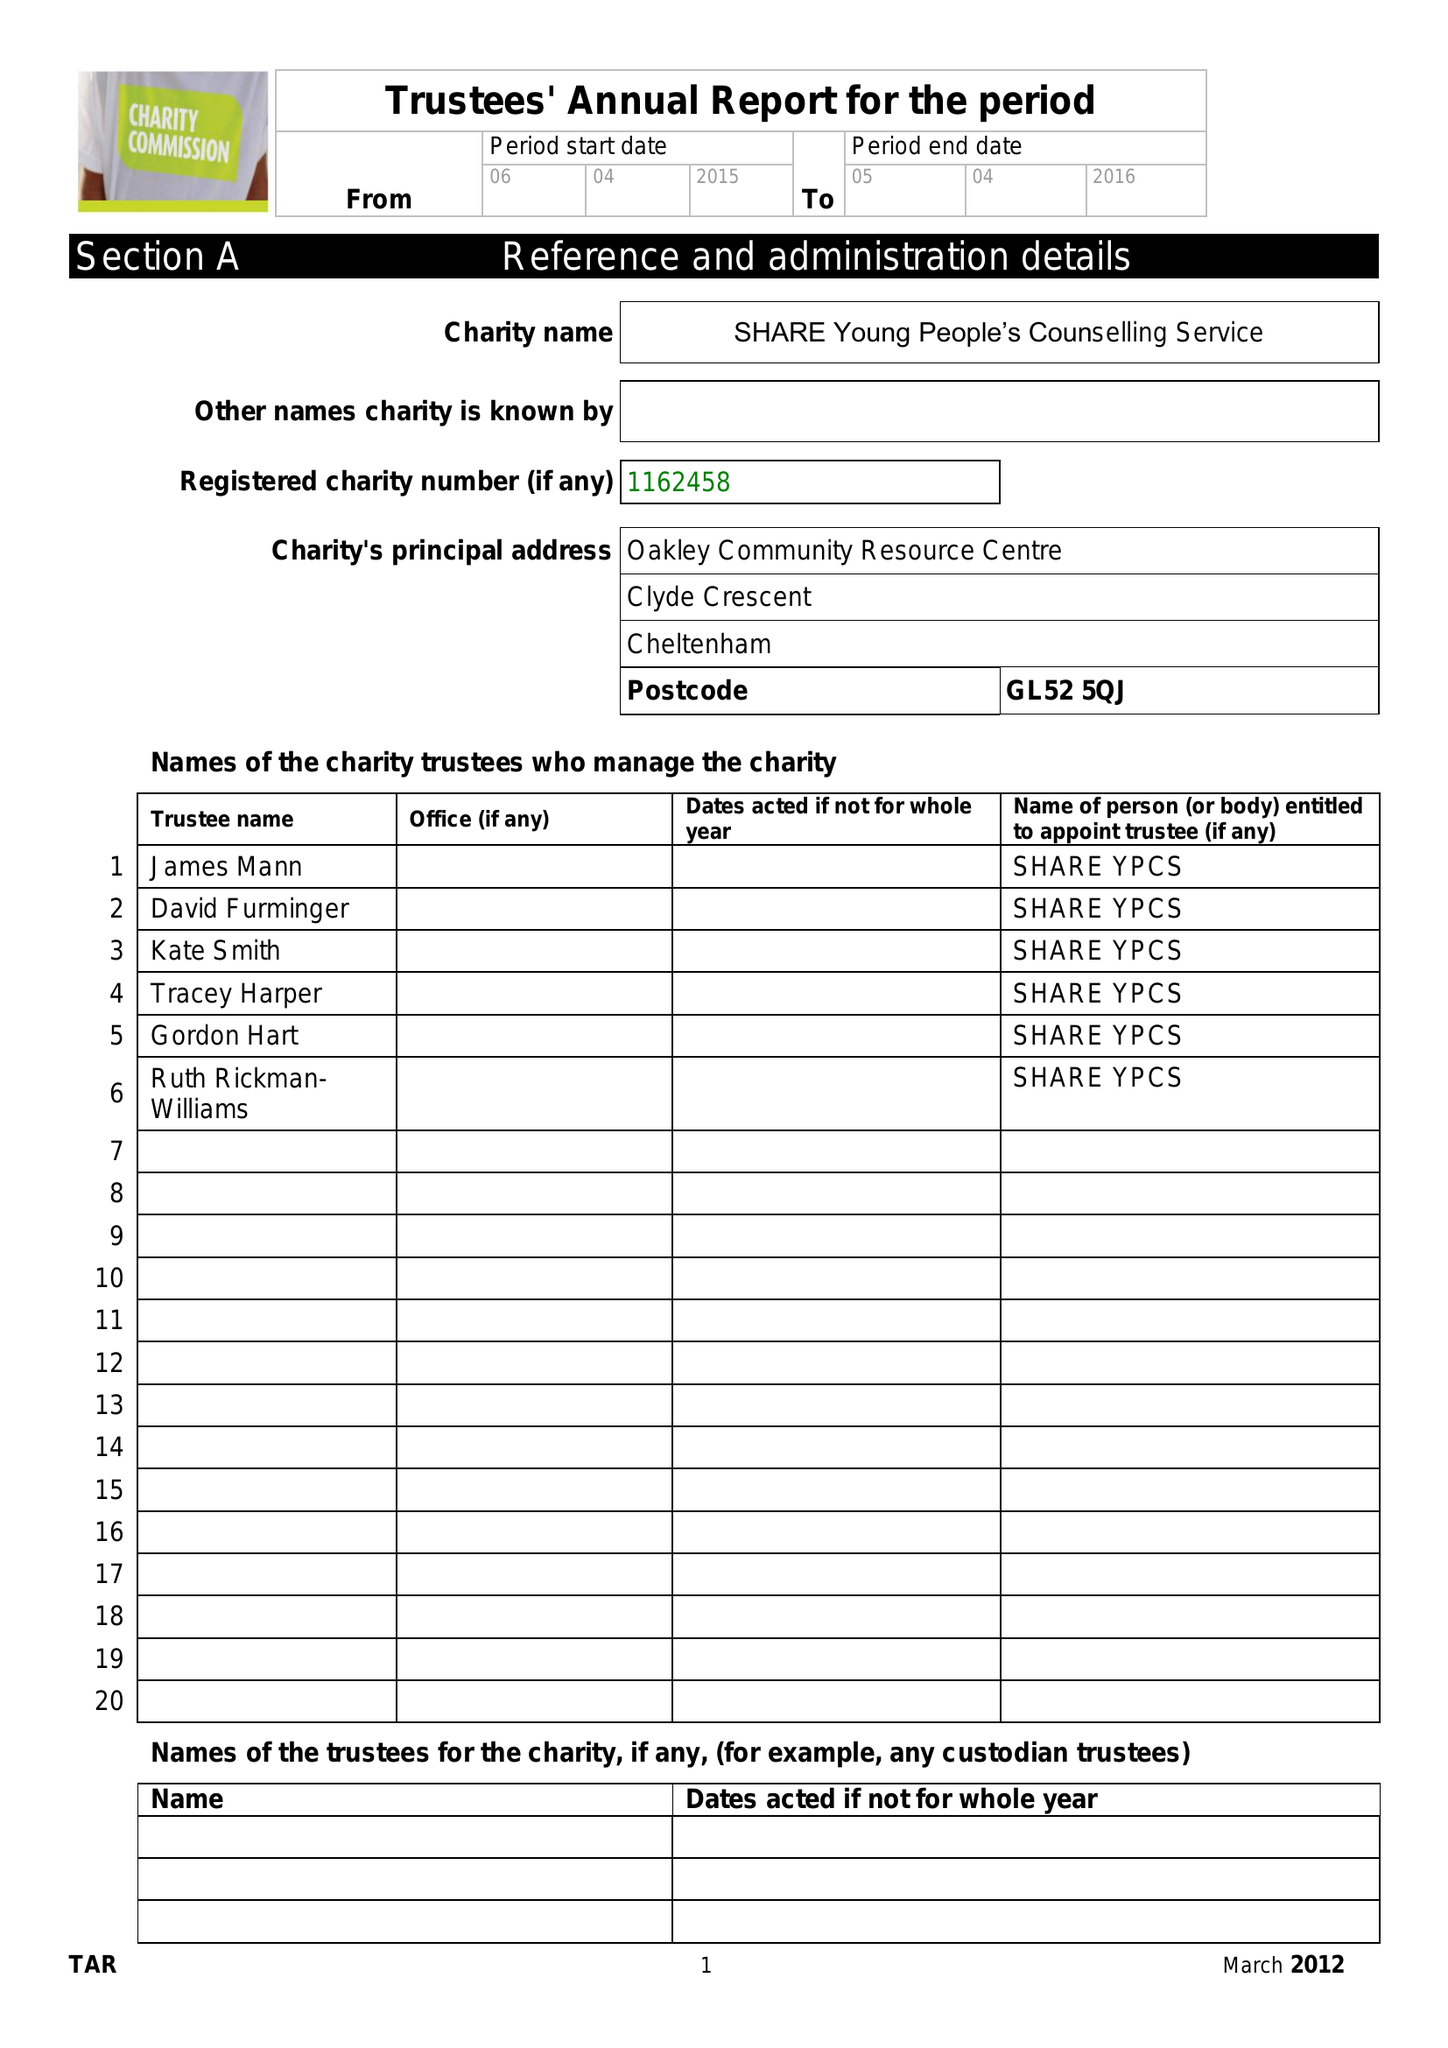What is the value for the spending_annually_in_british_pounds?
Answer the question using a single word or phrase. 50.00 